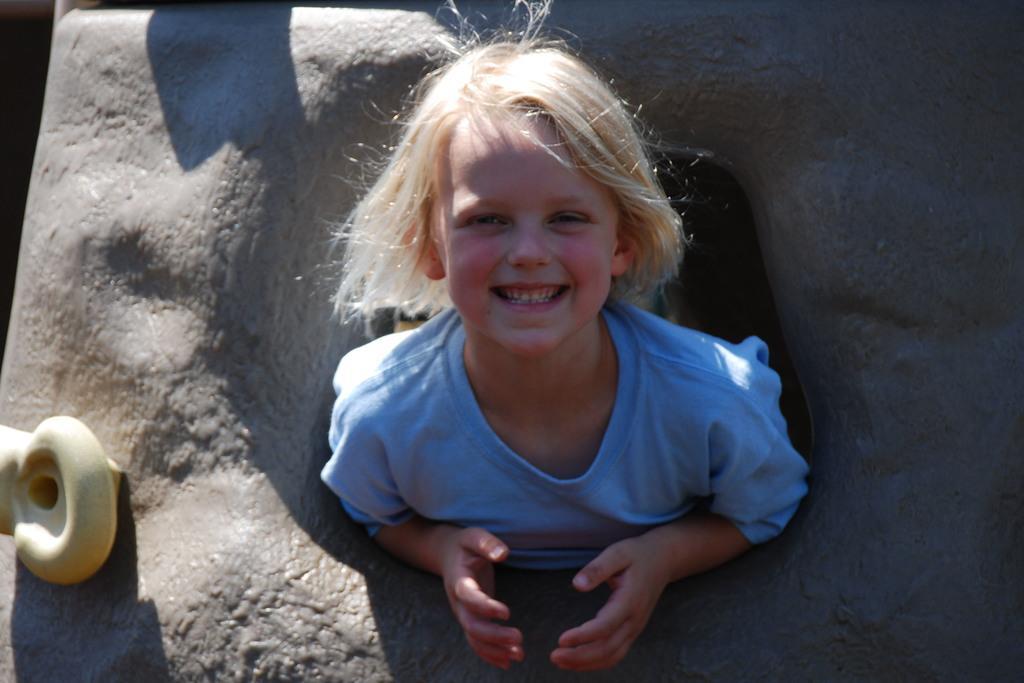How would you summarize this image in a sentence or two? In this picture we can see a girl smiling and some objects. 